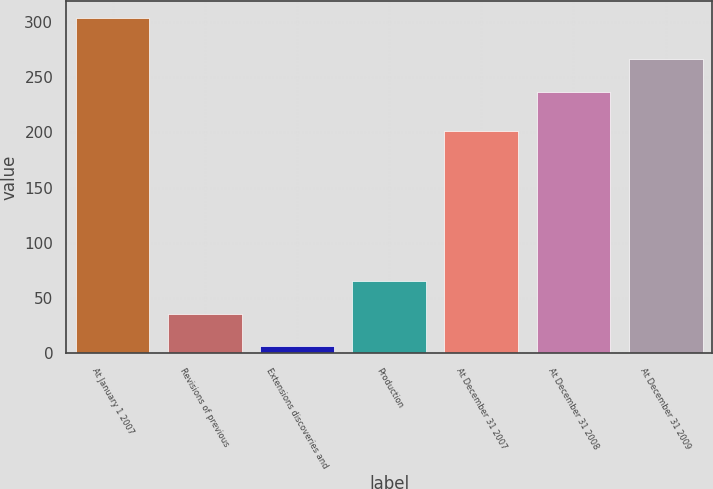Convert chart. <chart><loc_0><loc_0><loc_500><loc_500><bar_chart><fcel>At January 1 2007<fcel>Revisions of previous<fcel>Extensions discoveries and<fcel>Production<fcel>At December 31 2007<fcel>At December 31 2008<fcel>At December 31 2009<nl><fcel>304<fcel>35.8<fcel>6<fcel>65.6<fcel>201<fcel>237<fcel>266.8<nl></chart> 